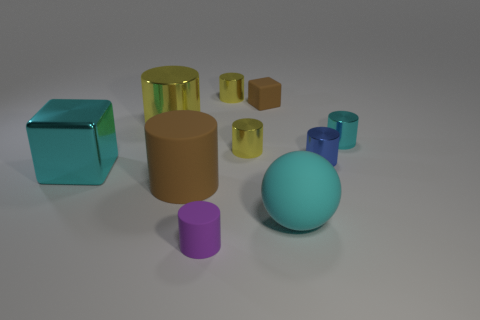Does the shiny thing that is to the right of the small blue metallic thing have the same shape as the large brown object?
Provide a short and direct response. Yes. What number of objects are either large metal things or cyan metal cylinders?
Keep it short and to the point. 3. Does the block that is left of the tiny brown object have the same material as the brown cylinder?
Your answer should be compact. No. How big is the matte block?
Offer a terse response. Small. What shape is the large metallic thing that is the same color as the big matte sphere?
Provide a succinct answer. Cube. What number of blocks are small cyan shiny objects or big cyan matte things?
Offer a very short reply. 0. Is the number of large things that are in front of the large cyan rubber thing the same as the number of rubber balls left of the large brown thing?
Your answer should be compact. Yes. The cyan metallic thing that is the same shape as the small brown object is what size?
Give a very brief answer. Large. How big is the cyan thing that is both behind the large brown object and left of the small cyan cylinder?
Your answer should be compact. Large. There is a large block; are there any big blocks in front of it?
Your answer should be compact. No. 